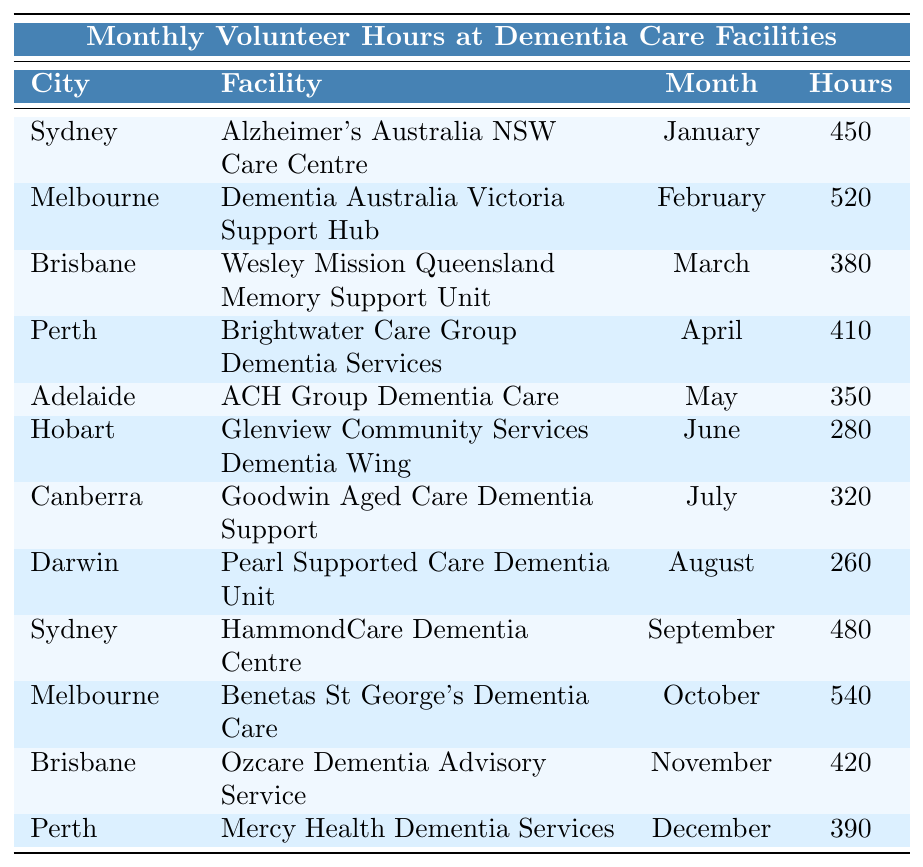What are the total volunteer hours recorded in Sydney? In the table, Sydney has two entries: January with 450 hours and September with 480 hours. Adding these gives 450 + 480 = 930 hours.
Answer: 930 Which city had the highest number of volunteer hours in a single month? By examining the table, I find that Melbourne, in October, recorded the highest with 540 hours.
Answer: Melbourne How many months recorded volunteer hours below 300? Looking at the table, I see Hobart in June (280) and Darwin in August (260), totaling 2 months below 300 hours.
Answer: 2 What is the average number of volunteer hours across all cities in May? In May, only Adelaide recorded 350 hours. Since there is one entry, the average is 350/1 = 350.
Answer: 350 Which facility in Melbourne had the highest volunteer hours and how many were recorded? In Melbourne, the entry for October shows Benetas St George's Dementia Care with 540 hours, which is the highest for that city.
Answer: 540 What is the difference in volunteer hours between the highest and lowest recorded months? The highest recorded month is in October (540 hours in Melbourne) and the lowest is August (260 hours in Darwin). The difference is 540 - 260 = 280 hours.
Answer: 280 How many total volunteer hours were recorded in the second half of the year (July to December)? Reviewing the second half: July (320), August (260), September (480), October (540), November (420), December (390). Adding these gives: 320 + 260 + 480 + 540 + 420 + 390 = 2,200 hours.
Answer: 2200 Which city's facility had the lowest volunteer hours recorded, and what was that number? Looking through the table, Darwin's Pearl Supported Care Dementia Unit in August had the lowest with 260 hours.
Answer: Darwin, 260 Was there any month without volunteer hours reported? All months in the table show recorded volunteer hours, so there were none without reported hours.
Answer: No What is the total volunteer hours for Brisbane across the year? Brisbane has March with 380 hours and November with 420 hours, totaling 380 + 420 = 800 hours for the year.
Answer: 800 